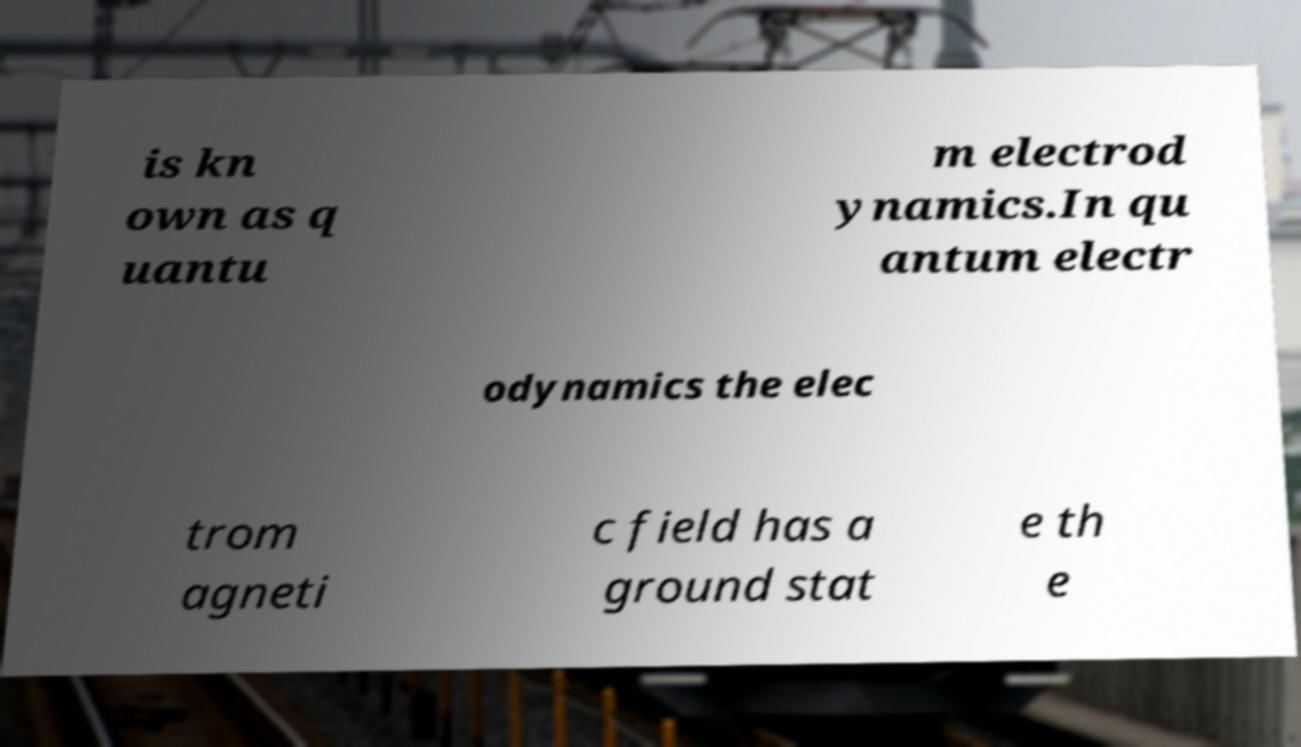Can you accurately transcribe the text from the provided image for me? is kn own as q uantu m electrod ynamics.In qu antum electr odynamics the elec trom agneti c field has a ground stat e th e 